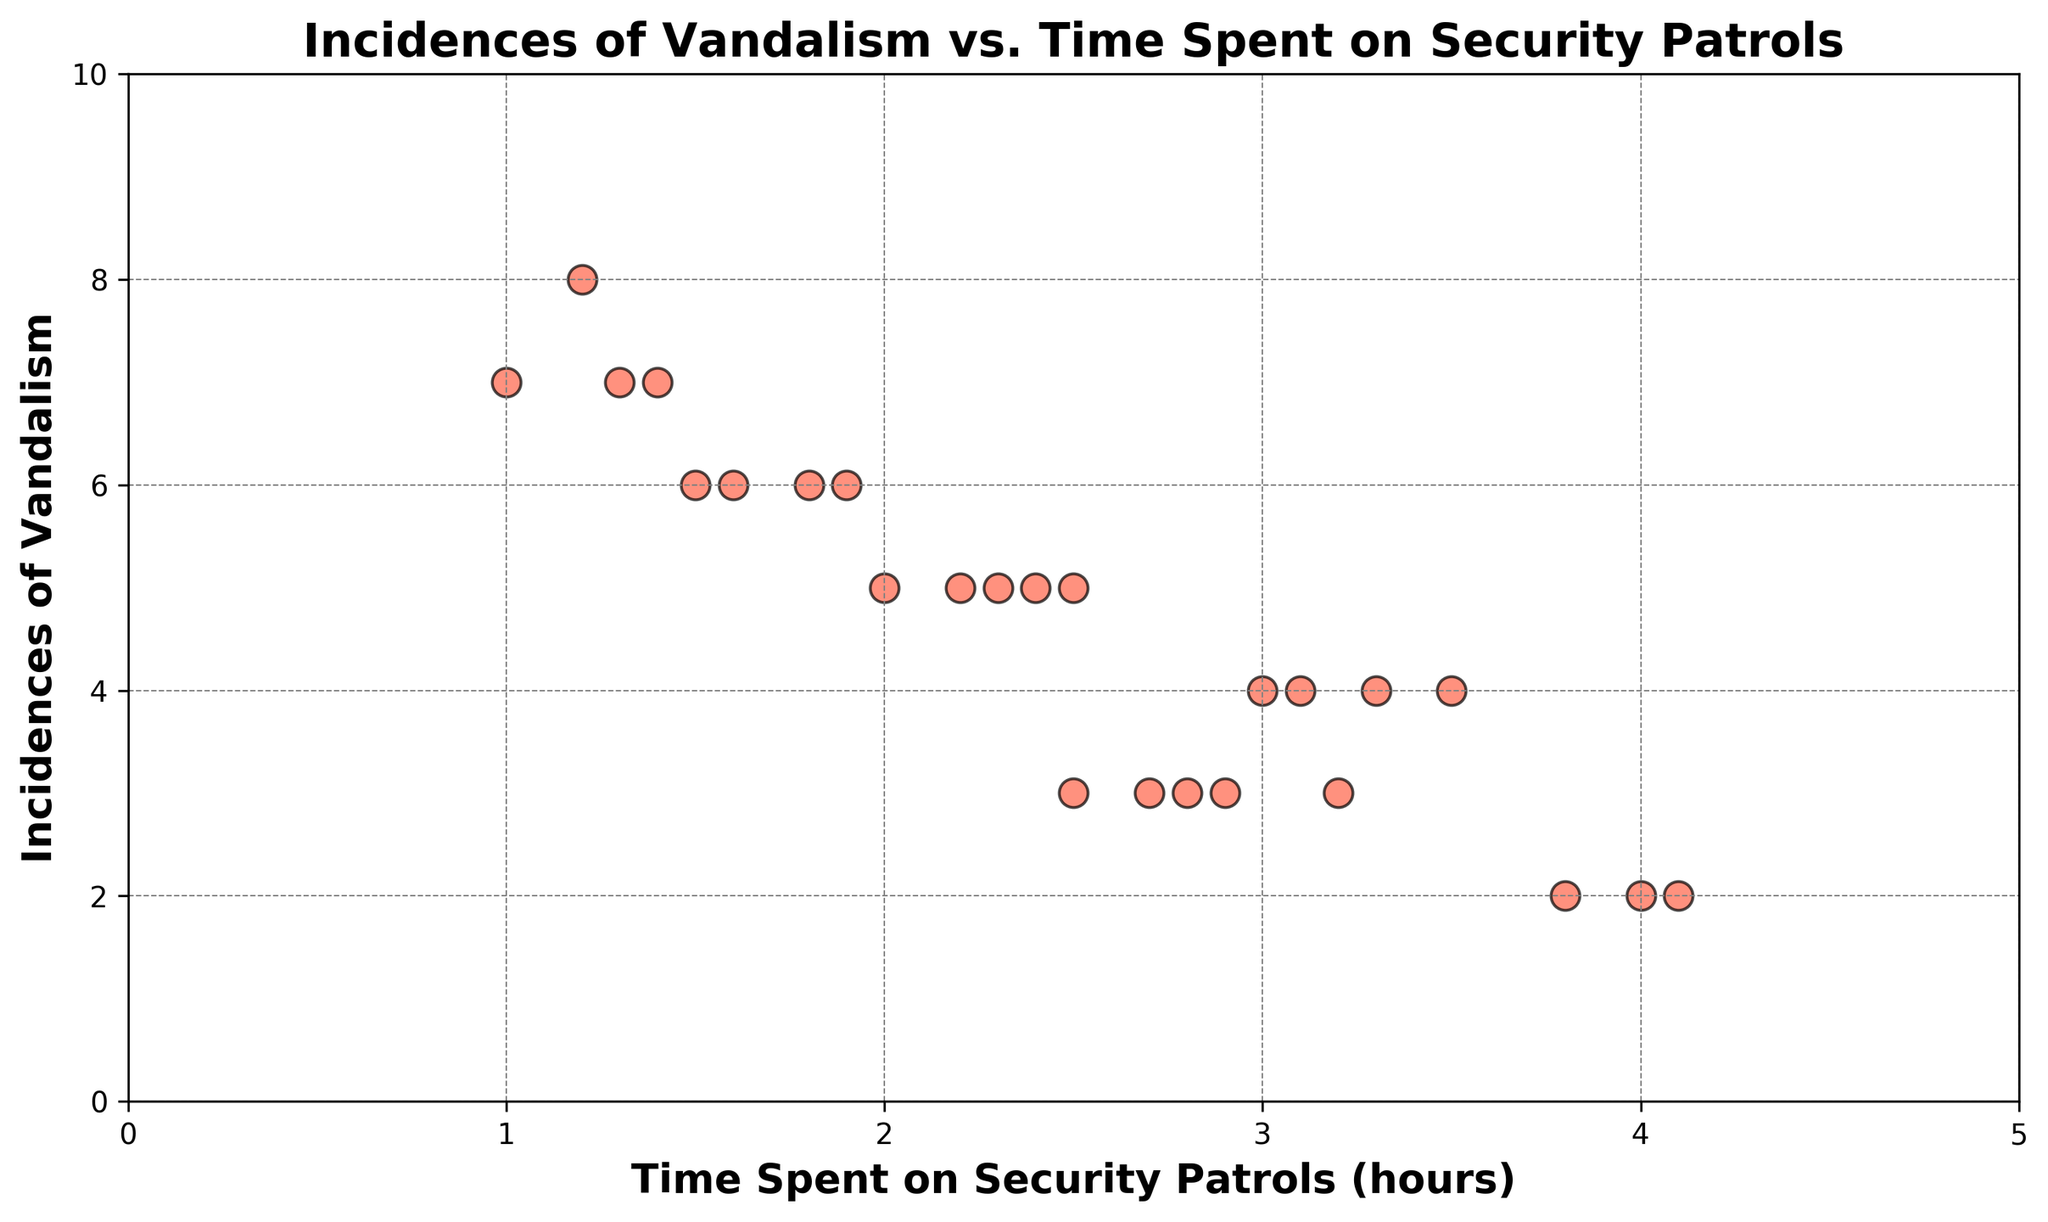what is the pattern between time spent on patrols and incidences of vandalism? To determine the pattern, we need to observe the trend in the scatter plot. It appears that incidents of vandalism decrease as the time spent on security patrols increases. Specifically, points with lower time spent patrols appear higher on the plot, indicating more vandalism. Conversely, those with higher patrol times are lower, indicating less vandalism.
Answer: Incidences decrease as patrol time increases which date had the highest incidence of vandalism and what was the time spent on patrols on that date? We need to find the highest point on the y-axis, corresponding to 8 incidences of vandalism. The data point reads 2023-01-10 with 1.2 hours spent on patrols.
Answer: 2023-01-10, 1.2 hours on what date was exactly 4 hours spent on security patrols and how many vandalism incidences were reported on that date? From the plot, locate the point exactly at 4 hours on the x-axis. The corresponding date is 2023-01-05 with 2 incidences of vandalism.
Answer: 2023-01-05, 2 incidences what is the average number of vandalism incidences when the time spent on patrols is less than 2 hours? First, identify the points with patrol times less than 2 hours. These points are on the x-axis: 2023-01-06 (7), 2023-01-10 (8), 2023-01-16 (7), 2023-01-21 (7). Average: (7 + 8+ 7 + 7) / 4 = 7.25.
Answer: 7.25 how many points show exactly 5 incidences of vandalism and what are the corresponding patrol times? Locate points at y=5: 2023-01-01 (2), 2023-01-08 (2.2), 2023-01-14 (2.4), 2023-01-19 (2.3), 2023-01-25 (2.5).
Answer: 5 points: 2, 2.2, 2.4, 2.3, 2.5 hours which time range has the most clustered vandalism incidences? Identify areas where points are densest. Most points seem clustered in the 2-3 hours range on the x-axis, showing varied incidences from 2-6.
Answer: 2-3 hours range how does changing the patrol time from 1.5 hours to 4 hours affect the number of vandalism incidences? Look at points: Patrol time of 1.5 hours (Jan 4, 6 incidences) and 4 hours (Jan 5, 2 incidences). Difference: 6-2=4 incidences decreased.
Answer: Decreases by 4 incidences compare the average vandalism incidences for patrol times longer than 3 hours and shorter times. Separate data >3 hours: 2, 4, 4, 2, 3, 3 points; average: (2+4+4+2+3+3)/6=3. Compare shorter: average previously aggregated finding higher.
Answer: Average decreases in higher patrol times 